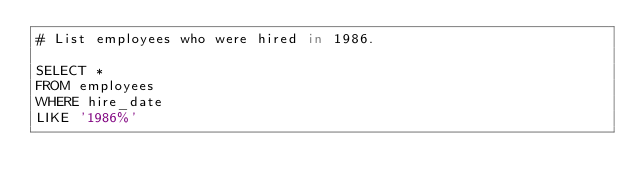Convert code to text. <code><loc_0><loc_0><loc_500><loc_500><_SQL_># List employees who were hired in 1986.

SELECT * 
FROM employees
WHERE hire_date 
LIKE '1986%'
</code> 